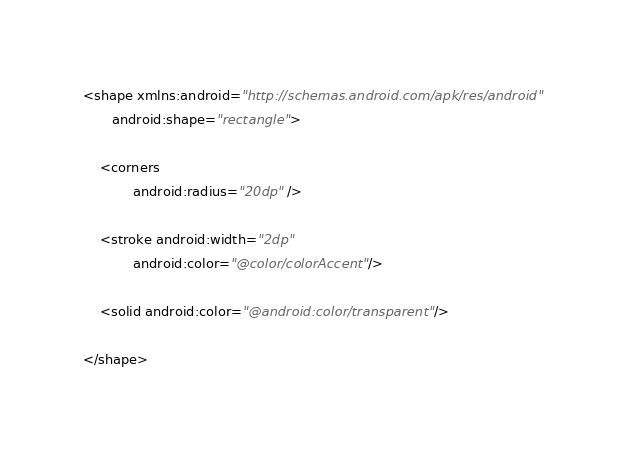Convert code to text. <code><loc_0><loc_0><loc_500><loc_500><_XML_><shape xmlns:android="http://schemas.android.com/apk/res/android"
       android:shape="rectangle">

    <corners
            android:radius="20dp" />

    <stroke android:width="2dp"
            android:color="@color/colorAccent"/>

    <solid android:color="@android:color/transparent"/>

</shape></code> 